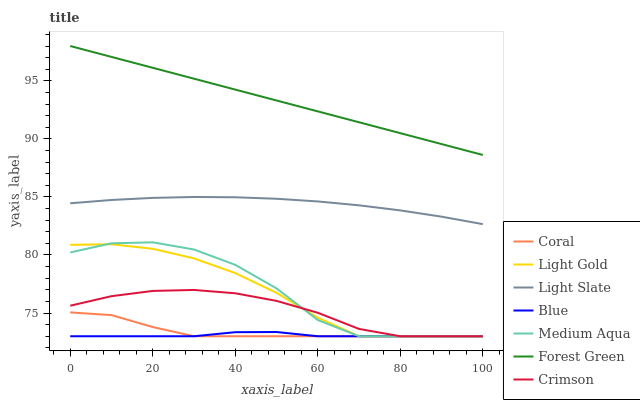Does Blue have the minimum area under the curve?
Answer yes or no. Yes. Does Forest Green have the maximum area under the curve?
Answer yes or no. Yes. Does Light Slate have the minimum area under the curve?
Answer yes or no. No. Does Light Slate have the maximum area under the curve?
Answer yes or no. No. Is Forest Green the smoothest?
Answer yes or no. Yes. Is Medium Aqua the roughest?
Answer yes or no. Yes. Is Light Slate the smoothest?
Answer yes or no. No. Is Light Slate the roughest?
Answer yes or no. No. Does Blue have the lowest value?
Answer yes or no. Yes. Does Light Slate have the lowest value?
Answer yes or no. No. Does Forest Green have the highest value?
Answer yes or no. Yes. Does Light Slate have the highest value?
Answer yes or no. No. Is Crimson less than Forest Green?
Answer yes or no. Yes. Is Forest Green greater than Light Slate?
Answer yes or no. Yes. Does Blue intersect Coral?
Answer yes or no. Yes. Is Blue less than Coral?
Answer yes or no. No. Is Blue greater than Coral?
Answer yes or no. No. Does Crimson intersect Forest Green?
Answer yes or no. No. 